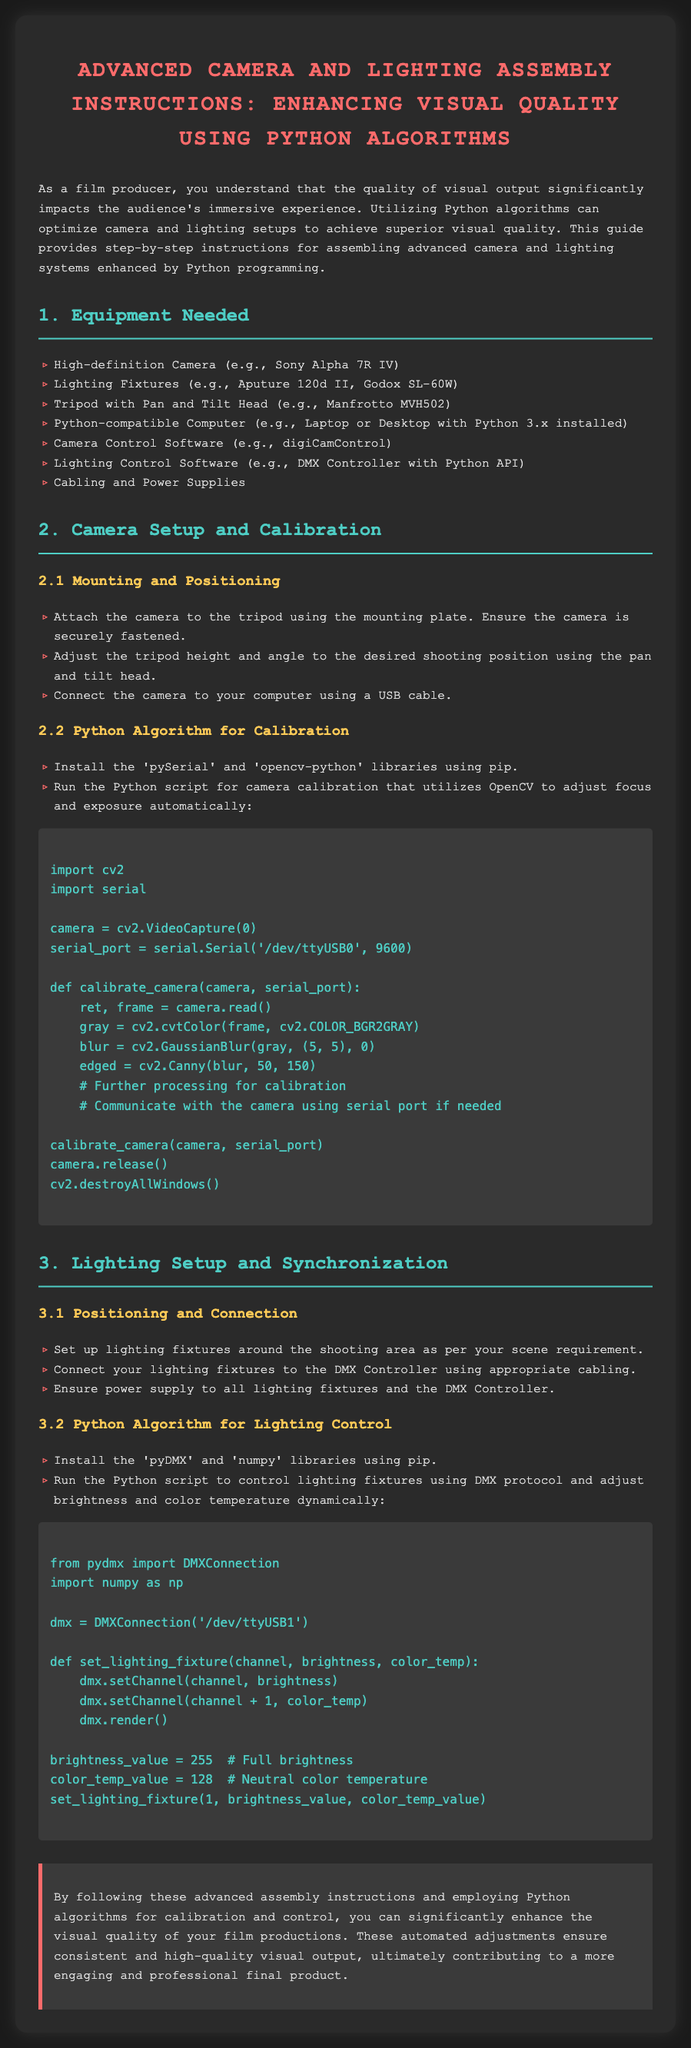What is the title of the document? The title is prominently displayed at the top of the document as the main heading.
Answer: Advanced Camera and Lighting Assembly Instructions: Enhancing Visual Quality Using Python Algorithms How many equipment items are listed? The number of items can be counted in the Equipment Needed section of the document.
Answer: Seven Which camera model is suggested for setup? The document specifies a suggested camera model in the Equipment Needed section.
Answer: Sony Alpha 7R IV What library is used for camera calibration in Python? The library mentioned in the Camera Setup and Calibration section for calibration.
Answer: opencv-python What is the brightness value set for the lighting fixture? The brightness value is specified in the Python script for Lighting Control.
Answer: 255 What type of controller is used for lighting fixtures? The document refers to a specific type of controller in the Lighting Setup and Synchronization section.
Answer: DMX Controller How is the camera connected to the computer? The document states how the connection is made within the Camera Setup and Calibration section.
Answer: USB cable What is the purpose of using Python algorithms in this assembly? This question requires understanding the document to encapsulate the overall purpose in one phrase.
Answer: Enhance visual quality What color temperature is set in the lighting control script? The specific color temperature value is provided in the Lighting Control section of the document.
Answer: 128 